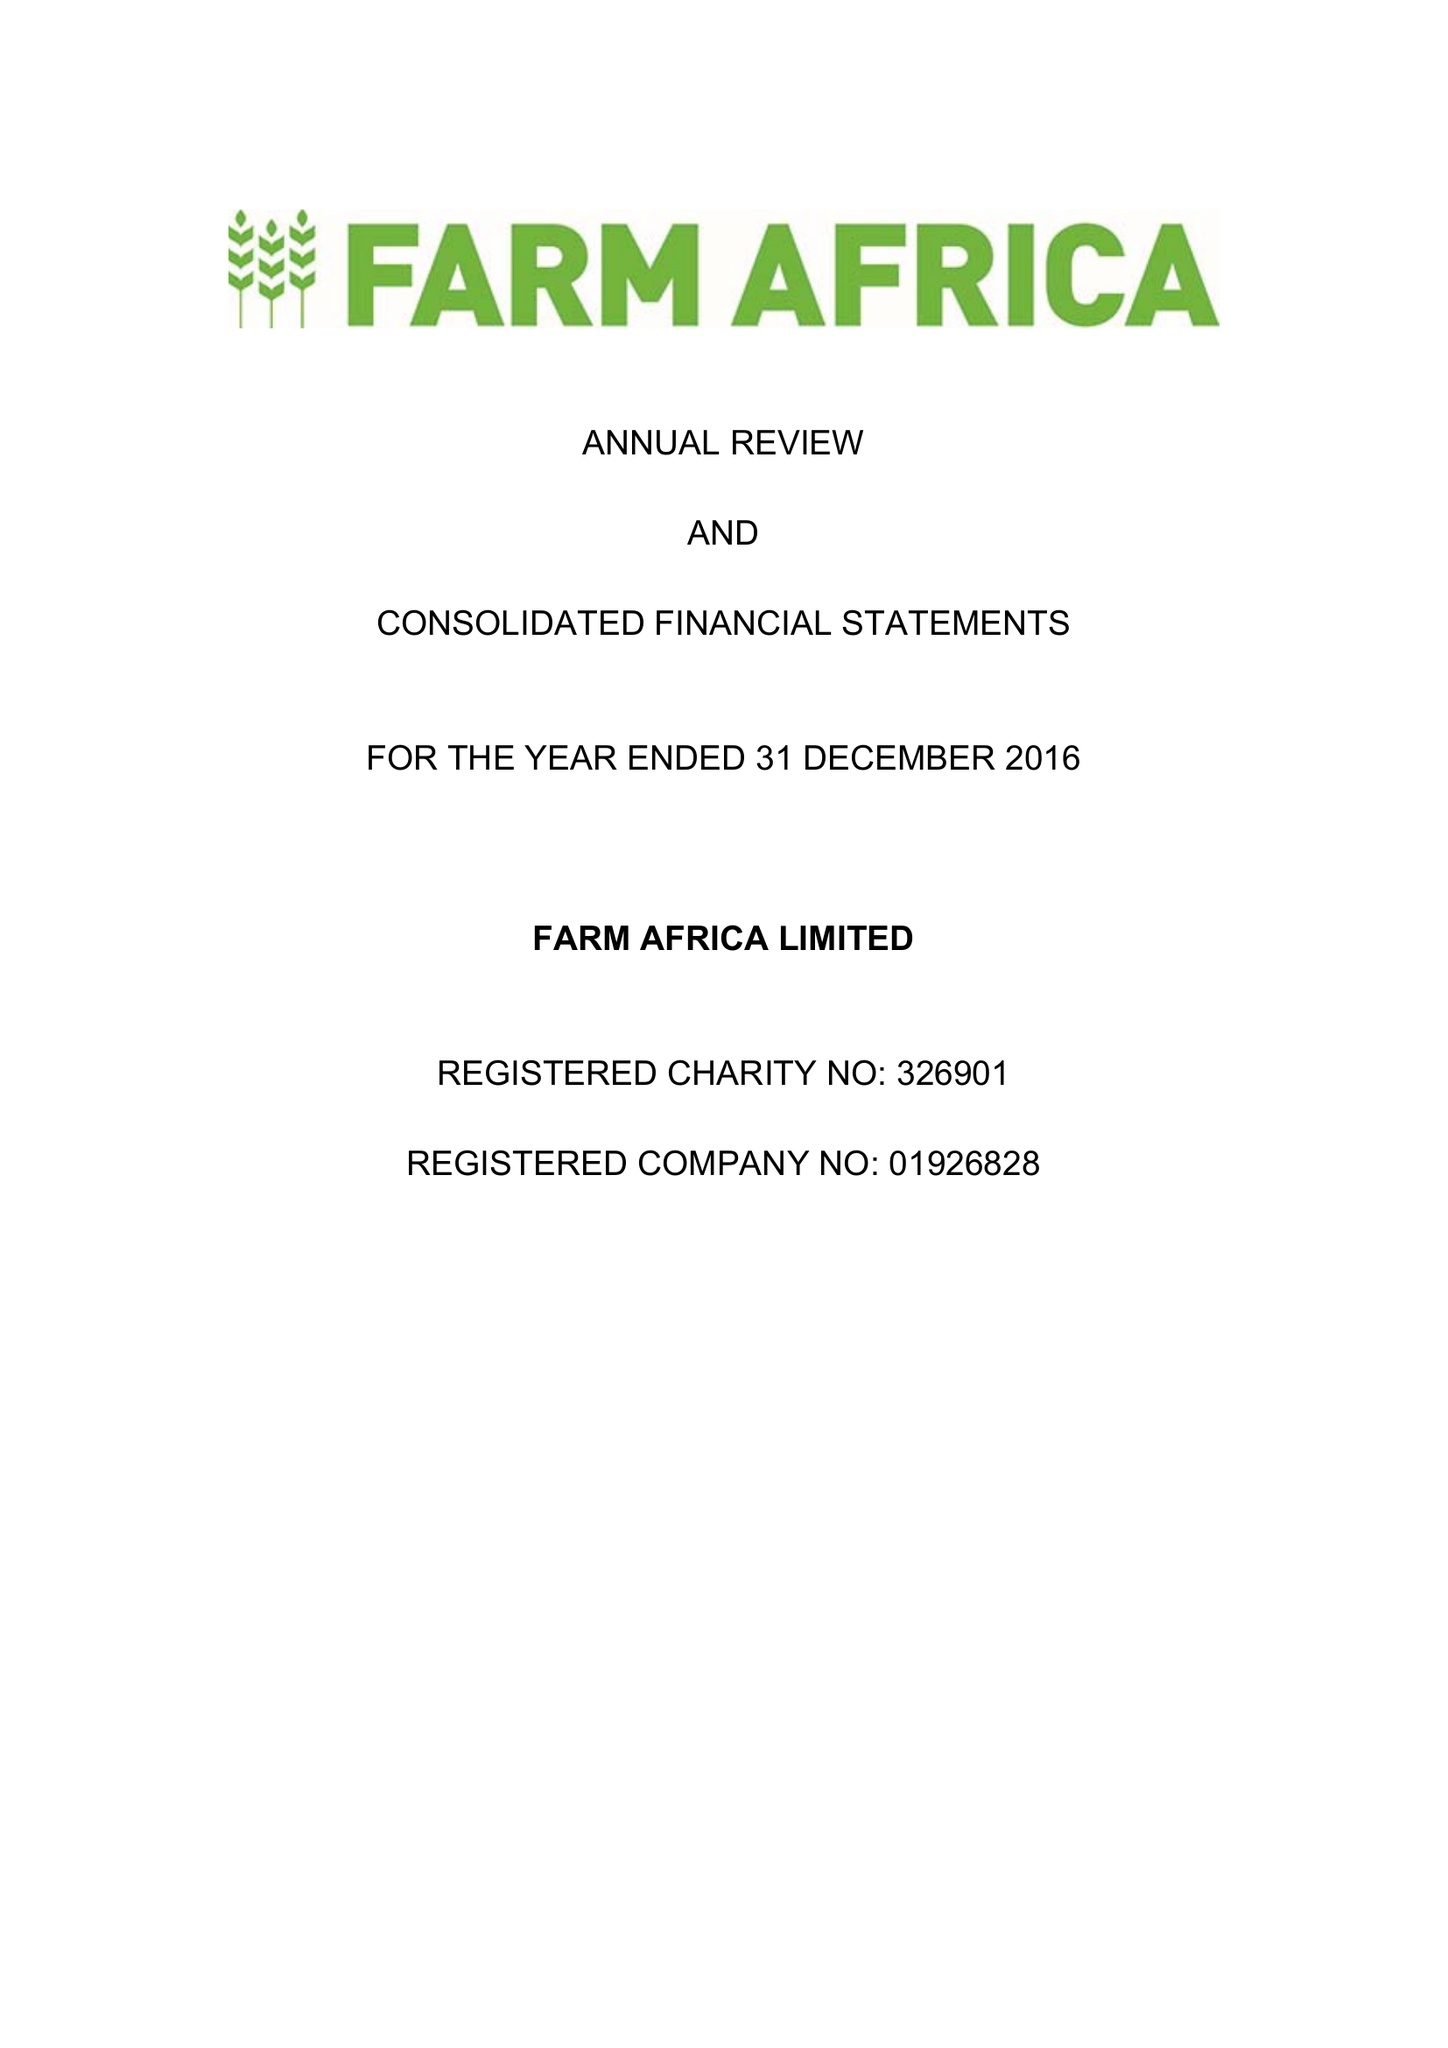What is the value for the address__street_line?
Answer the question using a single word or phrase. 140 LONDON WALL 